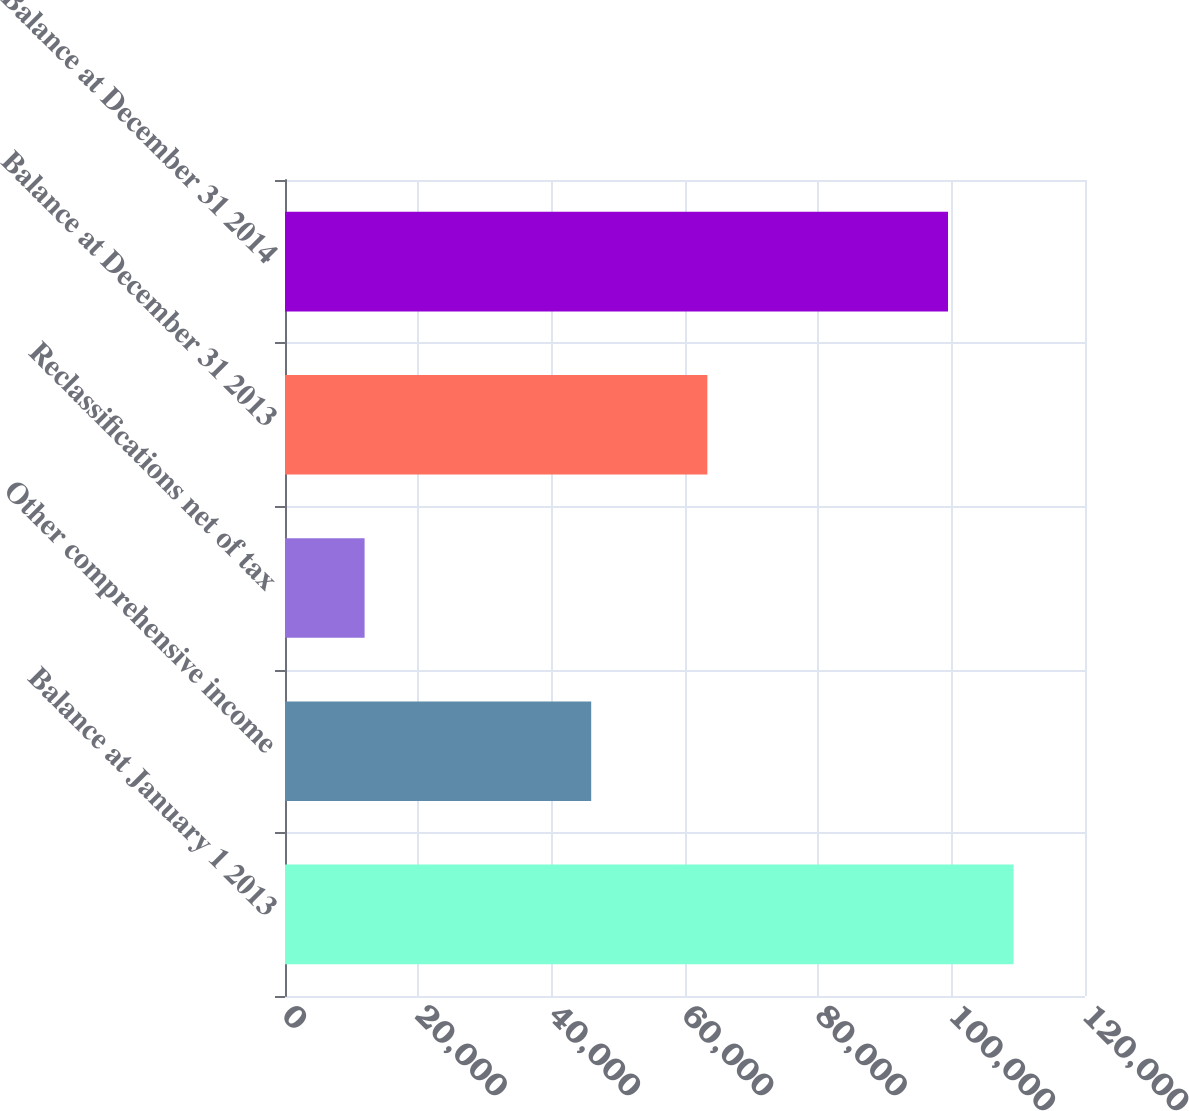Convert chart to OTSL. <chart><loc_0><loc_0><loc_500><loc_500><bar_chart><fcel>Balance at January 1 2013<fcel>Other comprehensive income<fcel>Reclassifications net of tax<fcel>Balance at December 31 2013<fcel>Balance at December 31 2014<nl><fcel>109283<fcel>45930<fcel>11938<fcel>63353<fcel>99449<nl></chart> 